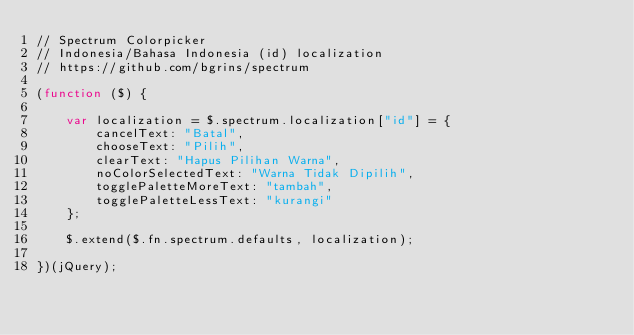<code> <loc_0><loc_0><loc_500><loc_500><_JavaScript_>// Spectrum Colorpicker
// Indonesia/Bahasa Indonesia (id) localization
// https://github.com/bgrins/spectrum

(function ($) {

    var localization = $.spectrum.localization["id"] = {
        cancelText: "Batal",
        chooseText: "Pilih",
        clearText: "Hapus Pilihan Warna",
        noColorSelectedText: "Warna Tidak Dipilih",
        togglePaletteMoreText: "tambah",
        togglePaletteLessText: "kurangi"
    };

    $.extend($.fn.spectrum.defaults, localization);

})(jQuery);
</code> 